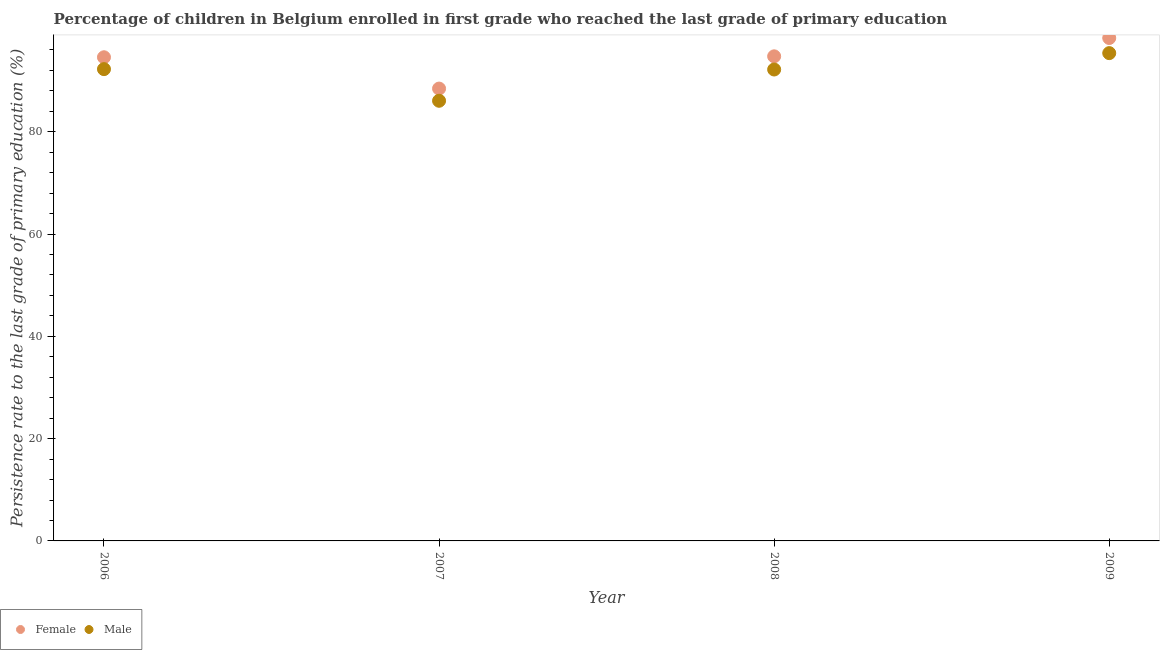How many different coloured dotlines are there?
Your answer should be compact. 2. What is the persistence rate of male students in 2009?
Your response must be concise. 95.37. Across all years, what is the maximum persistence rate of male students?
Make the answer very short. 95.37. Across all years, what is the minimum persistence rate of female students?
Your answer should be compact. 88.44. In which year was the persistence rate of male students maximum?
Keep it short and to the point. 2009. In which year was the persistence rate of male students minimum?
Your answer should be very brief. 2007. What is the total persistence rate of male students in the graph?
Offer a very short reply. 365.83. What is the difference between the persistence rate of male students in 2006 and that in 2008?
Your response must be concise. 0.07. What is the difference between the persistence rate of male students in 2007 and the persistence rate of female students in 2006?
Provide a succinct answer. -8.51. What is the average persistence rate of male students per year?
Provide a succinct answer. 91.46. In the year 2007, what is the difference between the persistence rate of female students and persistence rate of male students?
Provide a succinct answer. 2.38. What is the ratio of the persistence rate of female students in 2008 to that in 2009?
Your answer should be compact. 0.96. Is the persistence rate of male students in 2006 less than that in 2009?
Provide a succinct answer. Yes. What is the difference between the highest and the second highest persistence rate of female students?
Your answer should be very brief. 3.58. What is the difference between the highest and the lowest persistence rate of male students?
Make the answer very short. 9.32. Is the sum of the persistence rate of female students in 2006 and 2008 greater than the maximum persistence rate of male students across all years?
Offer a very short reply. Yes. Does the persistence rate of female students monotonically increase over the years?
Keep it short and to the point. No. Is the persistence rate of male students strictly less than the persistence rate of female students over the years?
Offer a very short reply. Yes. How many years are there in the graph?
Your response must be concise. 4. What is the difference between two consecutive major ticks on the Y-axis?
Make the answer very short. 20. How many legend labels are there?
Make the answer very short. 2. What is the title of the graph?
Provide a succinct answer. Percentage of children in Belgium enrolled in first grade who reached the last grade of primary education. Does "Resident" appear as one of the legend labels in the graph?
Make the answer very short. No. What is the label or title of the X-axis?
Ensure brevity in your answer.  Year. What is the label or title of the Y-axis?
Your answer should be very brief. Persistence rate to the last grade of primary education (%). What is the Persistence rate to the last grade of primary education (%) of Female in 2006?
Offer a terse response. 94.56. What is the Persistence rate to the last grade of primary education (%) in Male in 2006?
Ensure brevity in your answer.  92.24. What is the Persistence rate to the last grade of primary education (%) of Female in 2007?
Give a very brief answer. 88.44. What is the Persistence rate to the last grade of primary education (%) of Male in 2007?
Provide a short and direct response. 86.05. What is the Persistence rate to the last grade of primary education (%) in Female in 2008?
Your response must be concise. 94.75. What is the Persistence rate to the last grade of primary education (%) of Male in 2008?
Offer a very short reply. 92.17. What is the Persistence rate to the last grade of primary education (%) of Female in 2009?
Your answer should be very brief. 98.32. What is the Persistence rate to the last grade of primary education (%) in Male in 2009?
Ensure brevity in your answer.  95.37. Across all years, what is the maximum Persistence rate to the last grade of primary education (%) in Female?
Make the answer very short. 98.32. Across all years, what is the maximum Persistence rate to the last grade of primary education (%) of Male?
Your response must be concise. 95.37. Across all years, what is the minimum Persistence rate to the last grade of primary education (%) of Female?
Offer a very short reply. 88.44. Across all years, what is the minimum Persistence rate to the last grade of primary education (%) of Male?
Provide a succinct answer. 86.05. What is the total Persistence rate to the last grade of primary education (%) of Female in the graph?
Give a very brief answer. 376.07. What is the total Persistence rate to the last grade of primary education (%) of Male in the graph?
Ensure brevity in your answer.  365.83. What is the difference between the Persistence rate to the last grade of primary education (%) of Female in 2006 and that in 2007?
Keep it short and to the point. 6.12. What is the difference between the Persistence rate to the last grade of primary education (%) in Male in 2006 and that in 2007?
Keep it short and to the point. 6.19. What is the difference between the Persistence rate to the last grade of primary education (%) of Female in 2006 and that in 2008?
Give a very brief answer. -0.18. What is the difference between the Persistence rate to the last grade of primary education (%) in Male in 2006 and that in 2008?
Your answer should be compact. 0.07. What is the difference between the Persistence rate to the last grade of primary education (%) of Female in 2006 and that in 2009?
Offer a terse response. -3.76. What is the difference between the Persistence rate to the last grade of primary education (%) of Male in 2006 and that in 2009?
Your answer should be very brief. -3.13. What is the difference between the Persistence rate to the last grade of primary education (%) in Female in 2007 and that in 2008?
Your answer should be compact. -6.31. What is the difference between the Persistence rate to the last grade of primary education (%) in Male in 2007 and that in 2008?
Ensure brevity in your answer.  -6.11. What is the difference between the Persistence rate to the last grade of primary education (%) of Female in 2007 and that in 2009?
Your answer should be compact. -9.89. What is the difference between the Persistence rate to the last grade of primary education (%) of Male in 2007 and that in 2009?
Offer a terse response. -9.32. What is the difference between the Persistence rate to the last grade of primary education (%) of Female in 2008 and that in 2009?
Provide a succinct answer. -3.58. What is the difference between the Persistence rate to the last grade of primary education (%) in Male in 2008 and that in 2009?
Provide a succinct answer. -3.2. What is the difference between the Persistence rate to the last grade of primary education (%) in Female in 2006 and the Persistence rate to the last grade of primary education (%) in Male in 2007?
Ensure brevity in your answer.  8.51. What is the difference between the Persistence rate to the last grade of primary education (%) of Female in 2006 and the Persistence rate to the last grade of primary education (%) of Male in 2008?
Give a very brief answer. 2.39. What is the difference between the Persistence rate to the last grade of primary education (%) in Female in 2006 and the Persistence rate to the last grade of primary education (%) in Male in 2009?
Your answer should be very brief. -0.81. What is the difference between the Persistence rate to the last grade of primary education (%) of Female in 2007 and the Persistence rate to the last grade of primary education (%) of Male in 2008?
Offer a terse response. -3.73. What is the difference between the Persistence rate to the last grade of primary education (%) in Female in 2007 and the Persistence rate to the last grade of primary education (%) in Male in 2009?
Give a very brief answer. -6.93. What is the difference between the Persistence rate to the last grade of primary education (%) in Female in 2008 and the Persistence rate to the last grade of primary education (%) in Male in 2009?
Your answer should be compact. -0.63. What is the average Persistence rate to the last grade of primary education (%) in Female per year?
Provide a short and direct response. 94.02. What is the average Persistence rate to the last grade of primary education (%) of Male per year?
Offer a very short reply. 91.46. In the year 2006, what is the difference between the Persistence rate to the last grade of primary education (%) of Female and Persistence rate to the last grade of primary education (%) of Male?
Make the answer very short. 2.32. In the year 2007, what is the difference between the Persistence rate to the last grade of primary education (%) of Female and Persistence rate to the last grade of primary education (%) of Male?
Give a very brief answer. 2.38. In the year 2008, what is the difference between the Persistence rate to the last grade of primary education (%) of Female and Persistence rate to the last grade of primary education (%) of Male?
Keep it short and to the point. 2.58. In the year 2009, what is the difference between the Persistence rate to the last grade of primary education (%) of Female and Persistence rate to the last grade of primary education (%) of Male?
Ensure brevity in your answer.  2.95. What is the ratio of the Persistence rate to the last grade of primary education (%) of Female in 2006 to that in 2007?
Ensure brevity in your answer.  1.07. What is the ratio of the Persistence rate to the last grade of primary education (%) in Male in 2006 to that in 2007?
Your answer should be compact. 1.07. What is the ratio of the Persistence rate to the last grade of primary education (%) of Female in 2006 to that in 2008?
Your answer should be very brief. 1. What is the ratio of the Persistence rate to the last grade of primary education (%) of Female in 2006 to that in 2009?
Ensure brevity in your answer.  0.96. What is the ratio of the Persistence rate to the last grade of primary education (%) of Male in 2006 to that in 2009?
Your answer should be very brief. 0.97. What is the ratio of the Persistence rate to the last grade of primary education (%) in Female in 2007 to that in 2008?
Provide a succinct answer. 0.93. What is the ratio of the Persistence rate to the last grade of primary education (%) in Male in 2007 to that in 2008?
Make the answer very short. 0.93. What is the ratio of the Persistence rate to the last grade of primary education (%) of Female in 2007 to that in 2009?
Keep it short and to the point. 0.9. What is the ratio of the Persistence rate to the last grade of primary education (%) in Male in 2007 to that in 2009?
Your response must be concise. 0.9. What is the ratio of the Persistence rate to the last grade of primary education (%) in Female in 2008 to that in 2009?
Your response must be concise. 0.96. What is the ratio of the Persistence rate to the last grade of primary education (%) of Male in 2008 to that in 2009?
Keep it short and to the point. 0.97. What is the difference between the highest and the second highest Persistence rate to the last grade of primary education (%) in Female?
Provide a succinct answer. 3.58. What is the difference between the highest and the second highest Persistence rate to the last grade of primary education (%) of Male?
Give a very brief answer. 3.13. What is the difference between the highest and the lowest Persistence rate to the last grade of primary education (%) in Female?
Provide a succinct answer. 9.89. What is the difference between the highest and the lowest Persistence rate to the last grade of primary education (%) in Male?
Give a very brief answer. 9.32. 